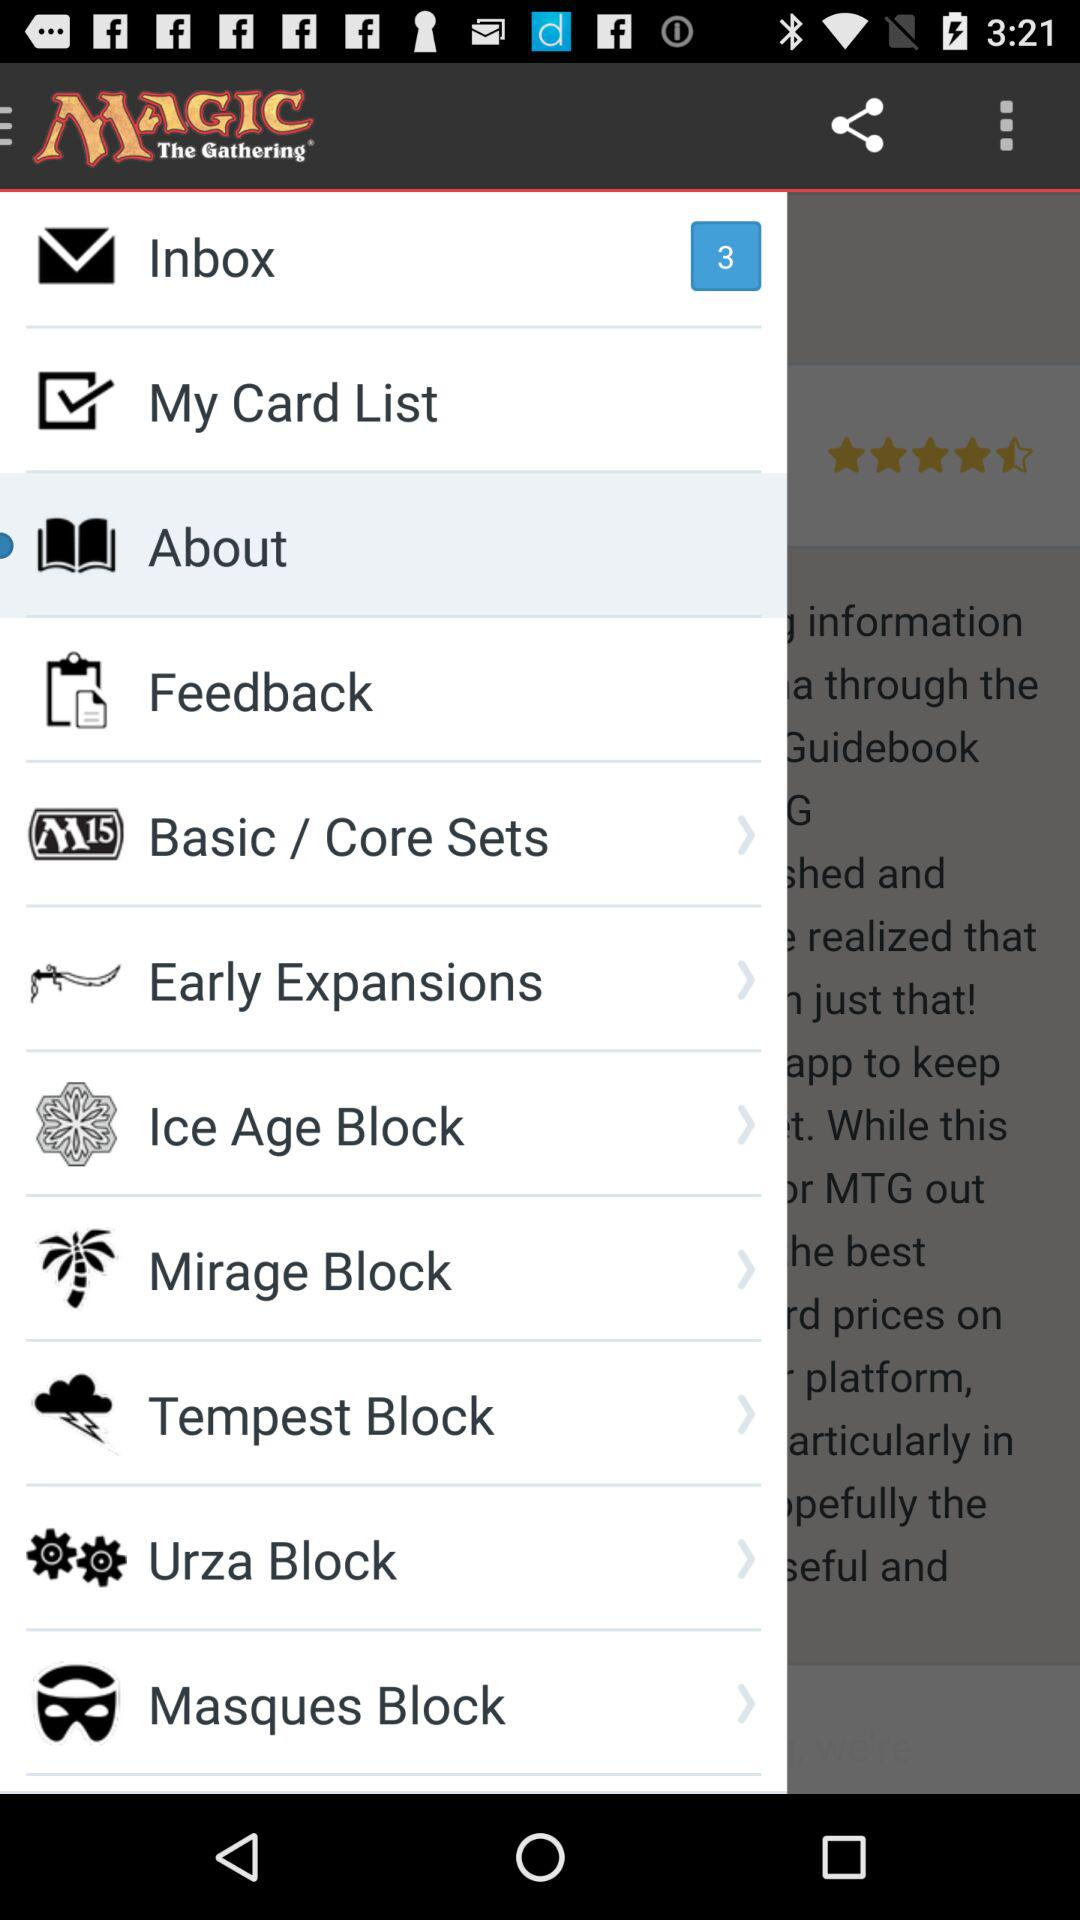Which item is selected? The selected item is "About". 